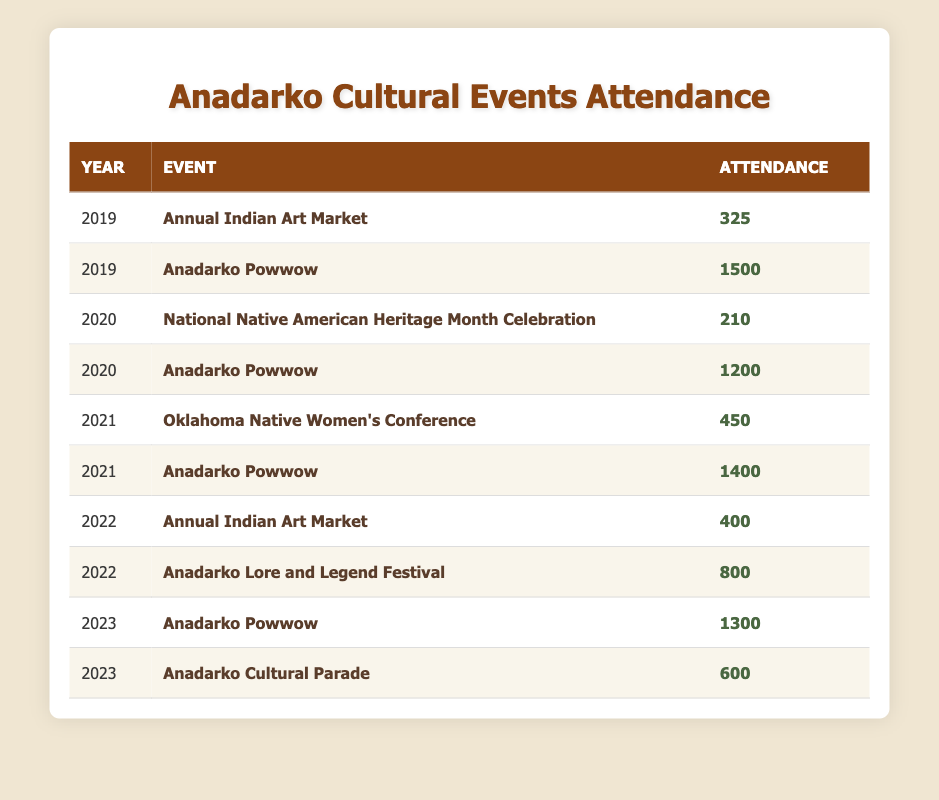What was the attendance at the Annual Indian Art Market in 2022? The table lists the attendance for the Annual Indian Art Market in 2022 as 400.
Answer: 400 What event had the highest attendance in 2019? In 2019, the table shows that the Anadarko Powwow had the highest attendance of 1500.
Answer: Anadarko Powwow How much did attendance at the Anadarko Powwow change from 2020 to 2023? The attendance for the Anadarko Powwow was 1200 in 2020 and 1300 in 2023, so the change in attendance is 1300 - 1200 = 100.
Answer: 100 Is the attendance at the Oklahoma Native Women’s Conference more than the attendance at the Annual Indian Art Market in 2022? The Oklahoma Native Women’s Conference had an attendance of 450, which is greater than the 400 attendees at the Annual Indian Art Market in 2022.
Answer: Yes What is the total attendance for all events in 2021? In 2021, the events listed are the Oklahoma Native Women's Conference with 450 and the Anadarko Powwow with 1400. The total attendance is 450 + 1400 = 1850.
Answer: 1850 Was the attendance at the Anadarko Cultural Parade greater than the attendance at the National Native American Heritage Month Celebration? The Anadarko Cultural Parade had an attendance of 600 while the National Native American Heritage Month Celebration had 210 attendees, so 600 is greater than 210.
Answer: Yes What was the average attendance for the Anadarko Powwow over the past five years? The attendance for the Anadarko Powwow over the years is 1500 (2019), 1200 (2020), 1400 (2021), 1300 (2023). The average is (1500 + 1200 + 1400 + 1300) / 4 = 1350.
Answer: 1350 How many attendees were at the events in 2022 compared to 2020? In 2022, the total attendance was 400 (Annual Indian Art Market) + 800 (Anadarko Lore and Legend Festival) = 1200. In 2020, the attendance was 210 (National Native American Heritage Month Celebration) + 1200 (Anadarko Powwow) = 1410. Comparing 1200 and 1410 shows that attendance in 2022 was less than in 2020.
Answer: Less What percentage of the total attendance in 2019 was from the Anadarko Powwow? The total attendance in 2019 was 325 (Annual Indian Art Market) + 1500 (Anadarko Powwow) = 1825. To find the percentage from the Powwow, (1500 / 1825) * 100 ≈ 82.64%.
Answer: 82.64% 